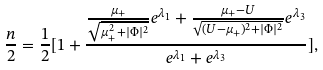<formula> <loc_0><loc_0><loc_500><loc_500>\frac { n } { 2 } = \frac { 1 } { 2 } [ 1 + \frac { \frac { \mu _ { + } } { \sqrt { \mu _ { + } ^ { 2 } + | \Phi | ^ { 2 } } } e ^ { \lambda _ { 1 } } + \frac { \mu _ { + } - U } { \sqrt { ( U - \mu _ { + } ) ^ { 2 } + | \Phi | ^ { 2 } } } e ^ { \lambda _ { 3 } } } { e ^ { \lambda _ { 1 } } + e ^ { \lambda _ { 3 } } } ] ,</formula> 